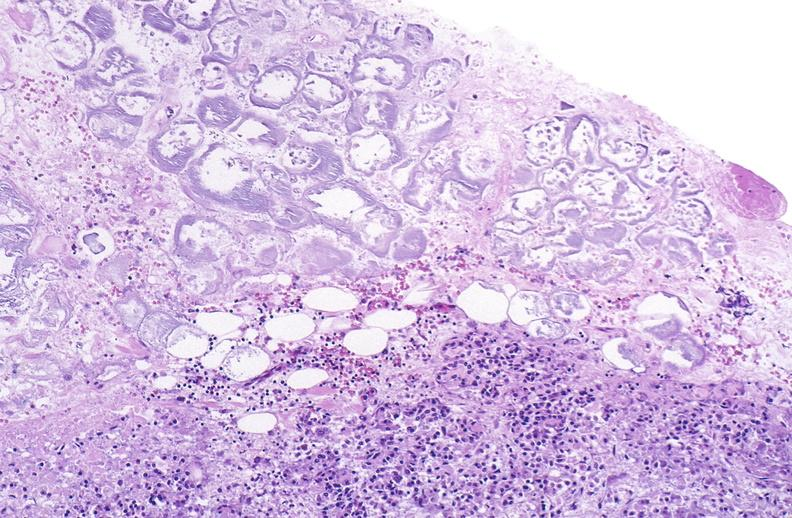where is this?
Answer the question using a single word or phrase. Pancreas 